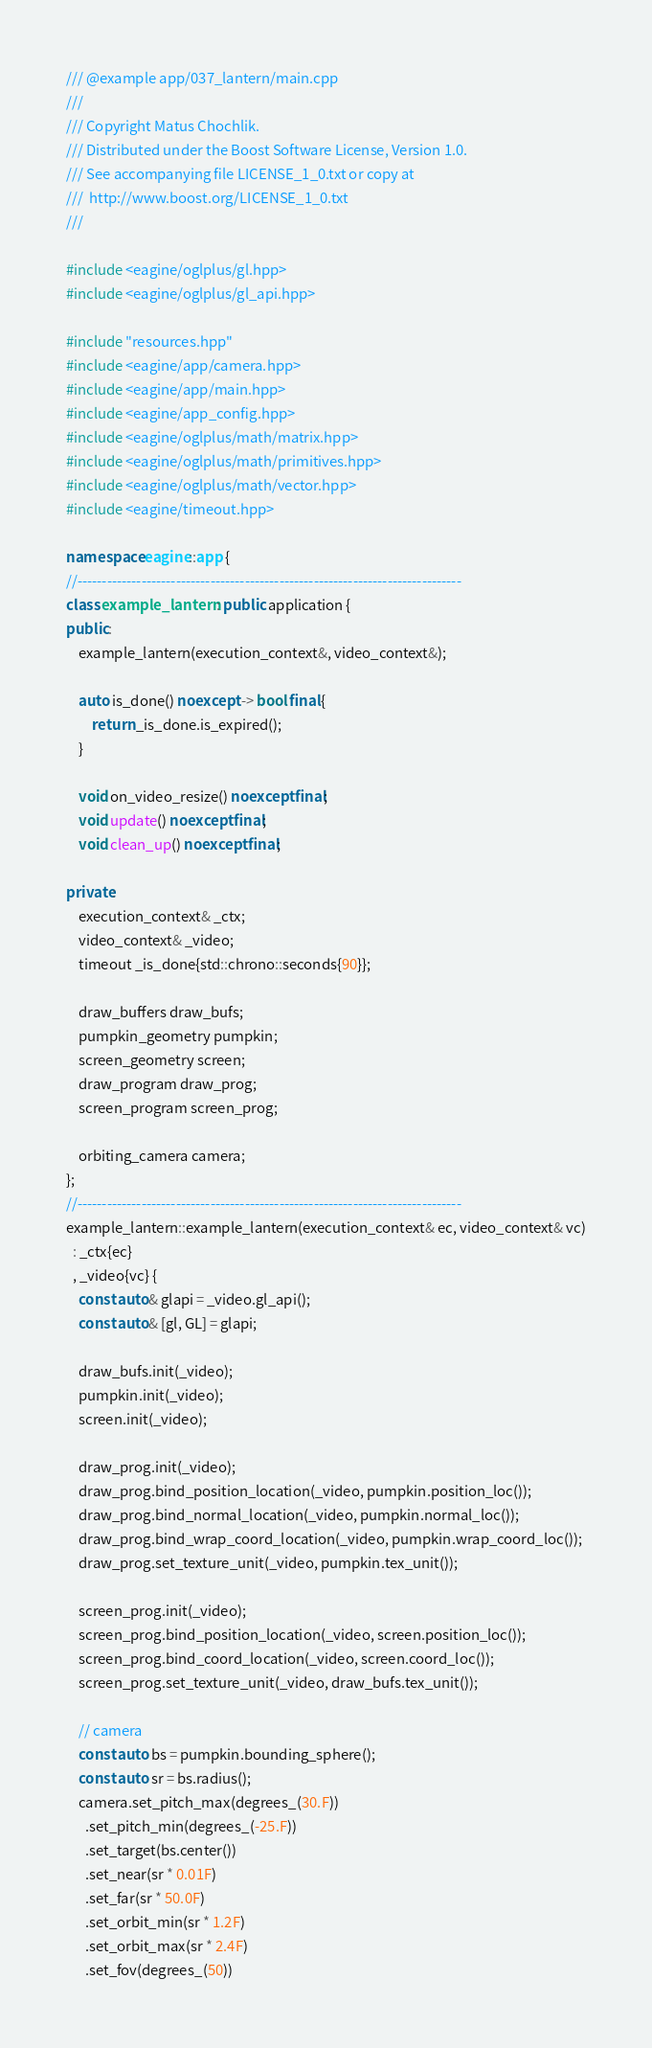Convert code to text. <code><loc_0><loc_0><loc_500><loc_500><_C++_>/// @example app/037_lantern/main.cpp
///
/// Copyright Matus Chochlik.
/// Distributed under the Boost Software License, Version 1.0.
/// See accompanying file LICENSE_1_0.txt or copy at
///  http://www.boost.org/LICENSE_1_0.txt
///

#include <eagine/oglplus/gl.hpp>
#include <eagine/oglplus/gl_api.hpp>

#include "resources.hpp"
#include <eagine/app/camera.hpp>
#include <eagine/app/main.hpp>
#include <eagine/app_config.hpp>
#include <eagine/oglplus/math/matrix.hpp>
#include <eagine/oglplus/math/primitives.hpp>
#include <eagine/oglplus/math/vector.hpp>
#include <eagine/timeout.hpp>

namespace eagine::app {
//------------------------------------------------------------------------------
class example_lantern : public application {
public:
    example_lantern(execution_context&, video_context&);

    auto is_done() noexcept -> bool final {
        return _is_done.is_expired();
    }

    void on_video_resize() noexcept final;
    void update() noexcept final;
    void clean_up() noexcept final;

private:
    execution_context& _ctx;
    video_context& _video;
    timeout _is_done{std::chrono::seconds{90}};

    draw_buffers draw_bufs;
    pumpkin_geometry pumpkin;
    screen_geometry screen;
    draw_program draw_prog;
    screen_program screen_prog;

    orbiting_camera camera;
};
//------------------------------------------------------------------------------
example_lantern::example_lantern(execution_context& ec, video_context& vc)
  : _ctx{ec}
  , _video{vc} {
    const auto& glapi = _video.gl_api();
    const auto& [gl, GL] = glapi;

    draw_bufs.init(_video);
    pumpkin.init(_video);
    screen.init(_video);

    draw_prog.init(_video);
    draw_prog.bind_position_location(_video, pumpkin.position_loc());
    draw_prog.bind_normal_location(_video, pumpkin.normal_loc());
    draw_prog.bind_wrap_coord_location(_video, pumpkin.wrap_coord_loc());
    draw_prog.set_texture_unit(_video, pumpkin.tex_unit());

    screen_prog.init(_video);
    screen_prog.bind_position_location(_video, screen.position_loc());
    screen_prog.bind_coord_location(_video, screen.coord_loc());
    screen_prog.set_texture_unit(_video, draw_bufs.tex_unit());

    // camera
    const auto bs = pumpkin.bounding_sphere();
    const auto sr = bs.radius();
    camera.set_pitch_max(degrees_(30.F))
      .set_pitch_min(degrees_(-25.F))
      .set_target(bs.center())
      .set_near(sr * 0.01F)
      .set_far(sr * 50.0F)
      .set_orbit_min(sr * 1.2F)
      .set_orbit_max(sr * 2.4F)
      .set_fov(degrees_(50))</code> 